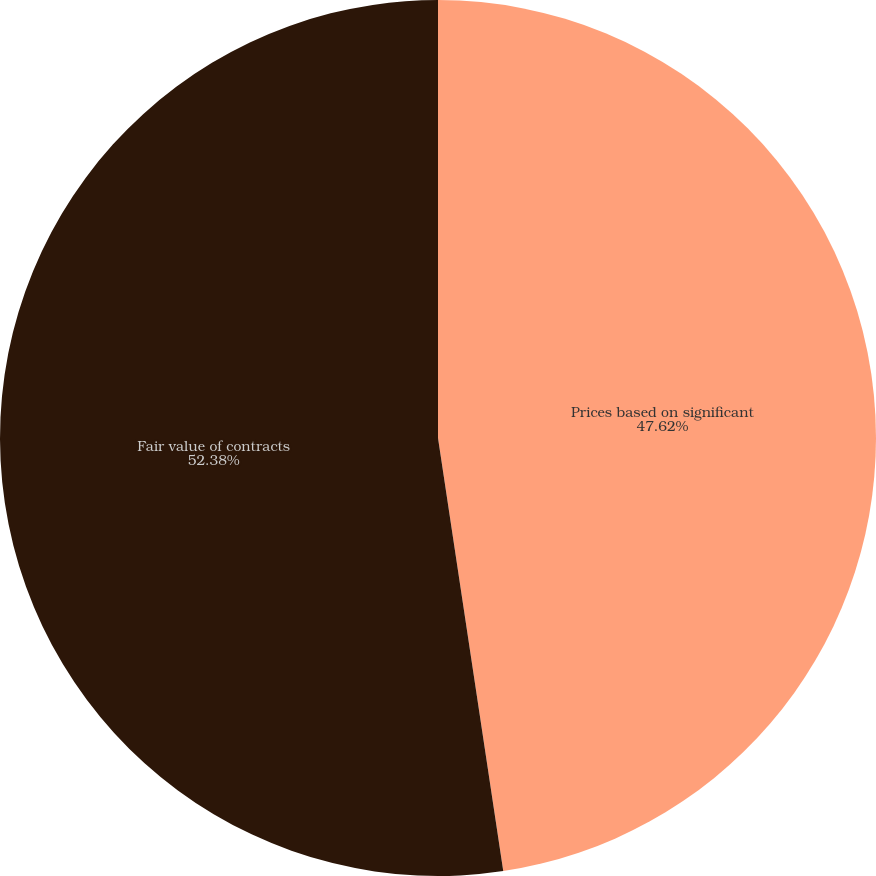Convert chart to OTSL. <chart><loc_0><loc_0><loc_500><loc_500><pie_chart><fcel>Prices based on significant<fcel>Fair value of contracts<nl><fcel>47.62%<fcel>52.38%<nl></chart> 